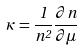Convert formula to latex. <formula><loc_0><loc_0><loc_500><loc_500>\kappa = \frac { 1 } { n ^ { 2 } } \frac { \partial n } { \partial \mu }</formula> 